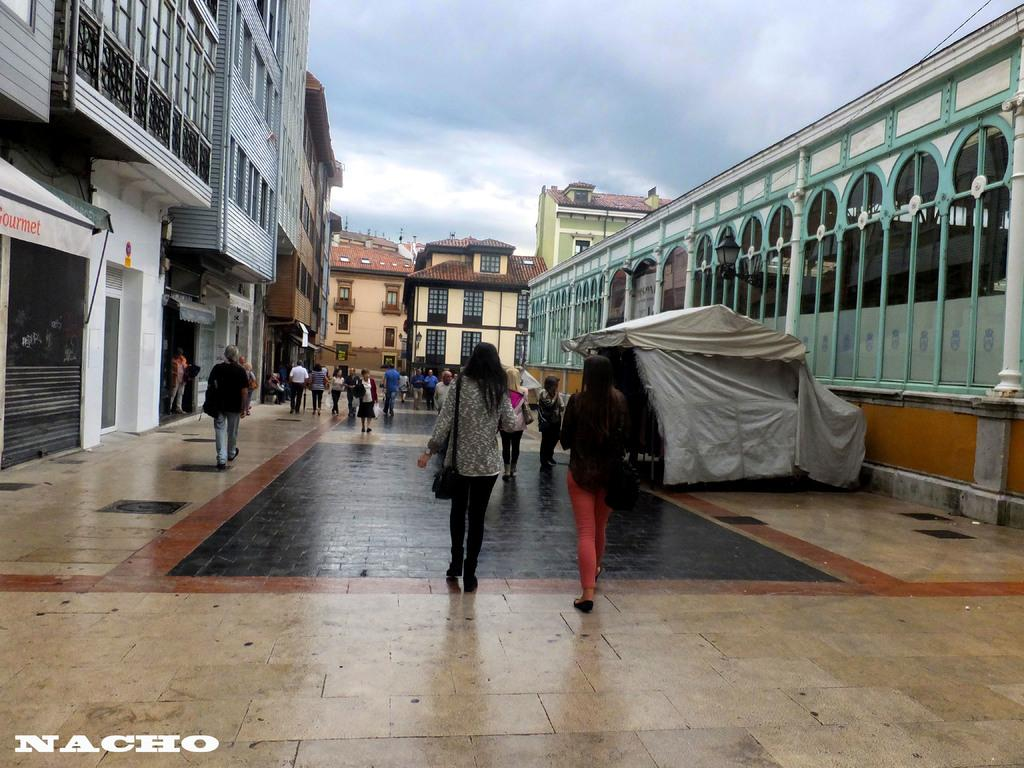What is the main focus of the image? The main focus of the image is the people in the center. What can be seen on the sides of the image? There are stalls on both the right and left sides of the image. What is visible in the background of the image? There are buildings in the background of the image. What type of swim gear can be seen on the people in the image? There is no swim gear visible in the image; the people are not swimming or engaging in any water-related activities. 